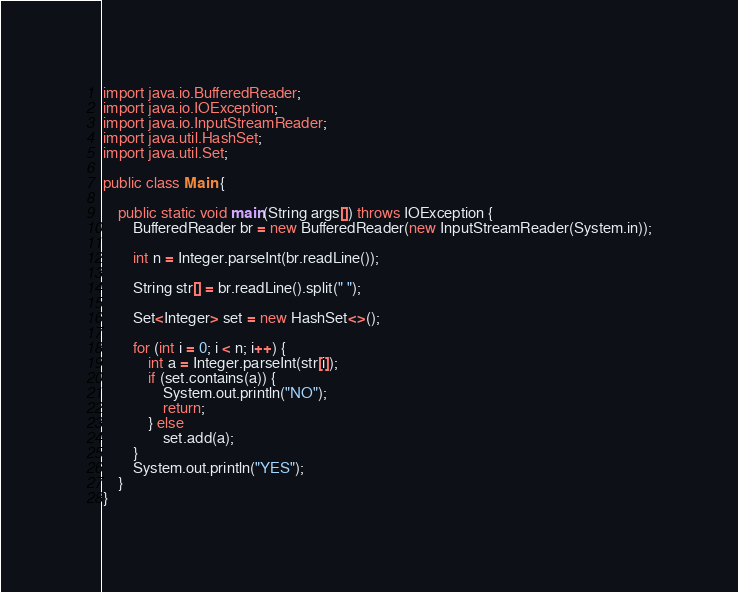Convert code to text. <code><loc_0><loc_0><loc_500><loc_500><_Java_>import java.io.BufferedReader;
import java.io.IOException;
import java.io.InputStreamReader;
import java.util.HashSet;
import java.util.Set;

public class Main {

	public static void main(String args[]) throws IOException {
		BufferedReader br = new BufferedReader(new InputStreamReader(System.in));

		int n = Integer.parseInt(br.readLine());

		String str[] = br.readLine().split(" ");

		Set<Integer> set = new HashSet<>();

		for (int i = 0; i < n; i++) {
			int a = Integer.parseInt(str[i]);
			if (set.contains(a)) {
				System.out.println("NO");
				return;
			} else
				set.add(a);
		}
		System.out.println("YES");
	}
}
</code> 